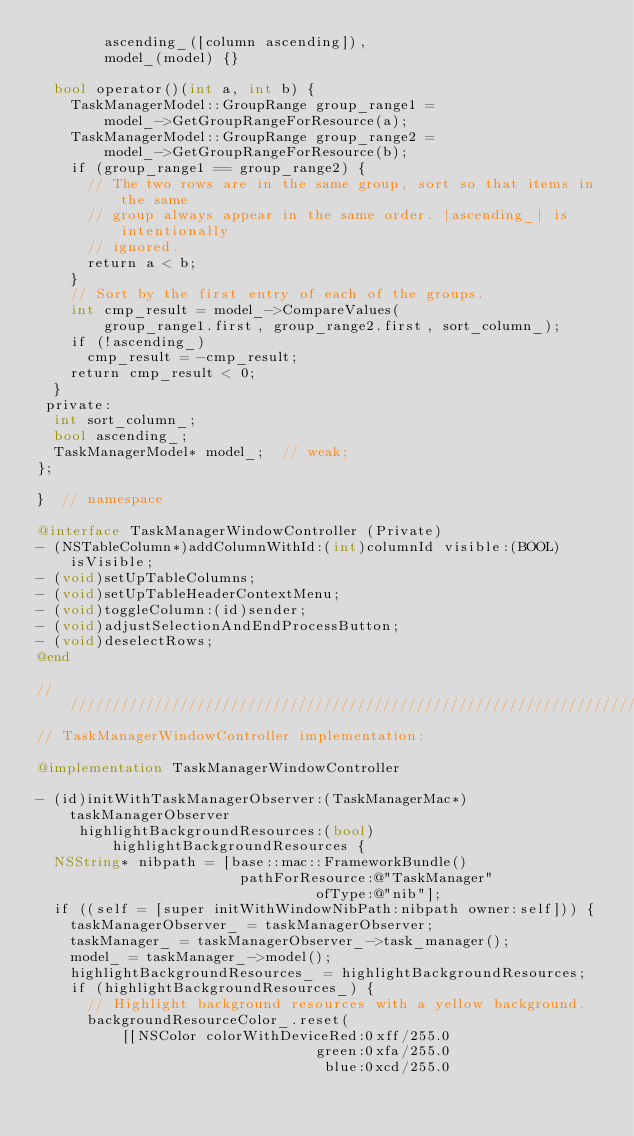<code> <loc_0><loc_0><loc_500><loc_500><_ObjectiveC_>        ascending_([column ascending]),
        model_(model) {}

  bool operator()(int a, int b) {
    TaskManagerModel::GroupRange group_range1 =
        model_->GetGroupRangeForResource(a);
    TaskManagerModel::GroupRange group_range2 =
        model_->GetGroupRangeForResource(b);
    if (group_range1 == group_range2) {
      // The two rows are in the same group, sort so that items in the same
      // group always appear in the same order. |ascending_| is intentionally
      // ignored.
      return a < b;
    }
    // Sort by the first entry of each of the groups.
    int cmp_result = model_->CompareValues(
        group_range1.first, group_range2.first, sort_column_);
    if (!ascending_)
      cmp_result = -cmp_result;
    return cmp_result < 0;
  }
 private:
  int sort_column_;
  bool ascending_;
  TaskManagerModel* model_;  // weak;
};

}  // namespace

@interface TaskManagerWindowController (Private)
- (NSTableColumn*)addColumnWithId:(int)columnId visible:(BOOL)isVisible;
- (void)setUpTableColumns;
- (void)setUpTableHeaderContextMenu;
- (void)toggleColumn:(id)sender;
- (void)adjustSelectionAndEndProcessButton;
- (void)deselectRows;
@end

////////////////////////////////////////////////////////////////////////////////
// TaskManagerWindowController implementation:

@implementation TaskManagerWindowController

- (id)initWithTaskManagerObserver:(TaskManagerMac*)taskManagerObserver
     highlightBackgroundResources:(bool)highlightBackgroundResources {
  NSString* nibpath = [base::mac::FrameworkBundle()
                        pathForResource:@"TaskManager"
                                 ofType:@"nib"];
  if ((self = [super initWithWindowNibPath:nibpath owner:self])) {
    taskManagerObserver_ = taskManagerObserver;
    taskManager_ = taskManagerObserver_->task_manager();
    model_ = taskManager_->model();
    highlightBackgroundResources_ = highlightBackgroundResources;
    if (highlightBackgroundResources_) {
      // Highlight background resources with a yellow background.
      backgroundResourceColor_.reset(
          [[NSColor colorWithDeviceRed:0xff/255.0
                                 green:0xfa/255.0
                                  blue:0xcd/255.0</code> 